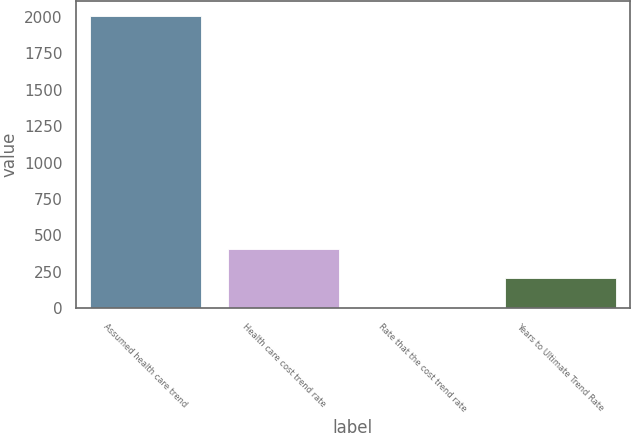<chart> <loc_0><loc_0><loc_500><loc_500><bar_chart><fcel>Assumed health care trend<fcel>Health care cost trend rate<fcel>Rate that the cost trend rate<fcel>Years to Ultimate Trend Rate<nl><fcel>2007<fcel>405.4<fcel>5<fcel>205.2<nl></chart> 